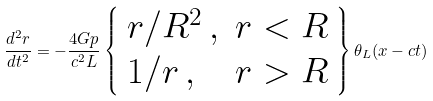<formula> <loc_0><loc_0><loc_500><loc_500>\frac { d ^ { 2 } r } { d t ^ { 2 } } = - \frac { 4 G p } { c ^ { 2 } L } \left \{ \begin{array} { l r } r / R ^ { 2 } \, , & r < R \\ 1 / r \, , & r > R \end{array} \right \} \theta _ { L } ( x - c t )</formula> 